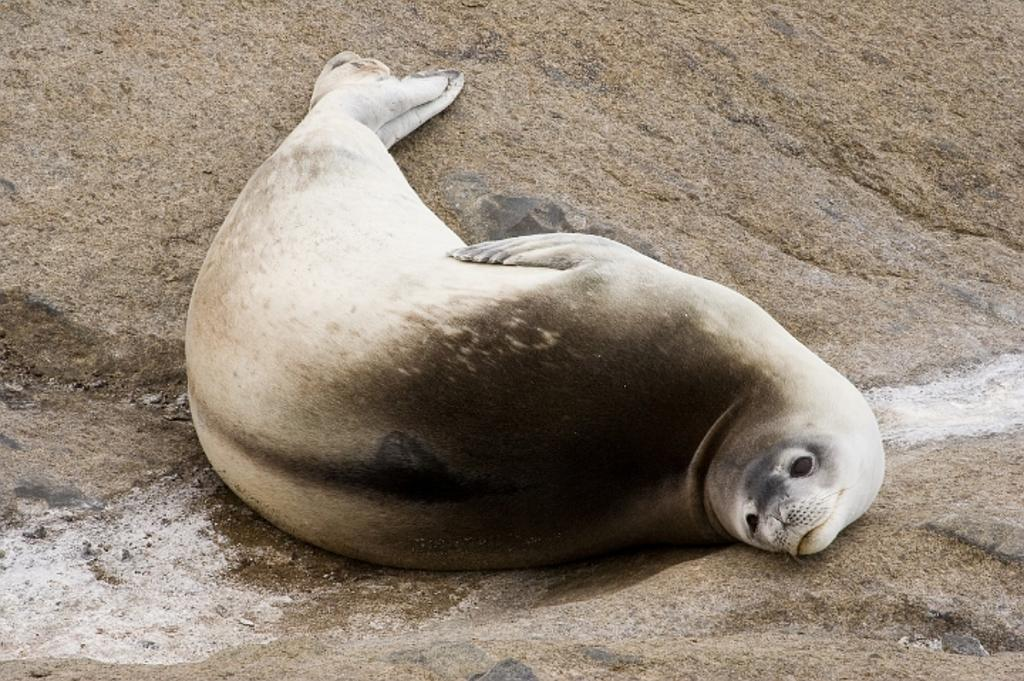What animal is featured in the picture? There is a sea lion in the picture. Where is the sea lion located? The sea lion is on the sand. What can be seen in the background of the picture? Water is visible in the picture. What type of humor is the sea lion displaying in the picture? The sea lion is not displaying any humor in the picture; it is simply resting on the sand. Is there a volcano visible in the picture? No, there is no volcano present in the picture. 